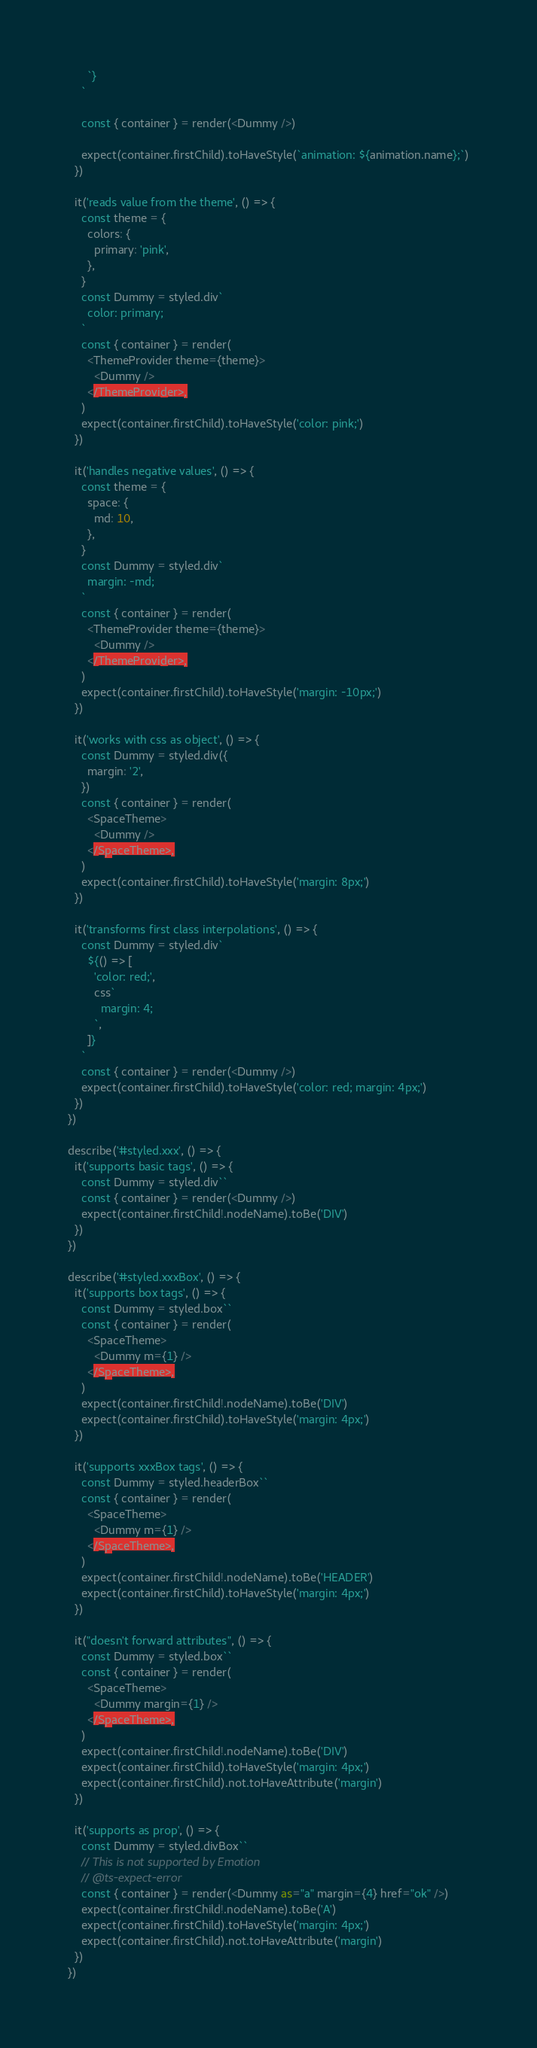<code> <loc_0><loc_0><loc_500><loc_500><_TypeScript_>      `}
    `

    const { container } = render(<Dummy />)

    expect(container.firstChild).toHaveStyle(`animation: ${animation.name};`)
  })

  it('reads value from the theme', () => {
    const theme = {
      colors: {
        primary: 'pink',
      },
    }
    const Dummy = styled.div`
      color: primary;
    `
    const { container } = render(
      <ThemeProvider theme={theme}>
        <Dummy />
      </ThemeProvider>,
    )
    expect(container.firstChild).toHaveStyle('color: pink;')
  })

  it('handles negative values', () => {
    const theme = {
      space: {
        md: 10,
      },
    }
    const Dummy = styled.div`
      margin: -md;
    `
    const { container } = render(
      <ThemeProvider theme={theme}>
        <Dummy />
      </ThemeProvider>,
    )
    expect(container.firstChild).toHaveStyle('margin: -10px;')
  })

  it('works with css as object', () => {
    const Dummy = styled.div({
      margin: '2',
    })
    const { container } = render(
      <SpaceTheme>
        <Dummy />
      </SpaceTheme>,
    )
    expect(container.firstChild).toHaveStyle('margin: 8px;')
  })

  it('transforms first class interpolations', () => {
    const Dummy = styled.div`
      ${() => [
        'color: red;',
        css`
          margin: 4;
        `,
      ]}
    `
    const { container } = render(<Dummy />)
    expect(container.firstChild).toHaveStyle('color: red; margin: 4px;')
  })
})

describe('#styled.xxx', () => {
  it('supports basic tags', () => {
    const Dummy = styled.div``
    const { container } = render(<Dummy />)
    expect(container.firstChild!.nodeName).toBe('DIV')
  })
})

describe('#styled.xxxBox', () => {
  it('supports box tags', () => {
    const Dummy = styled.box``
    const { container } = render(
      <SpaceTheme>
        <Dummy m={1} />
      </SpaceTheme>,
    )
    expect(container.firstChild!.nodeName).toBe('DIV')
    expect(container.firstChild).toHaveStyle('margin: 4px;')
  })

  it('supports xxxBox tags', () => {
    const Dummy = styled.headerBox``
    const { container } = render(
      <SpaceTheme>
        <Dummy m={1} />
      </SpaceTheme>,
    )
    expect(container.firstChild!.nodeName).toBe('HEADER')
    expect(container.firstChild).toHaveStyle('margin: 4px;')
  })

  it("doesn't forward attributes", () => {
    const Dummy = styled.box``
    const { container } = render(
      <SpaceTheme>
        <Dummy margin={1} />
      </SpaceTheme>,
    )
    expect(container.firstChild!.nodeName).toBe('DIV')
    expect(container.firstChild).toHaveStyle('margin: 4px;')
    expect(container.firstChild).not.toHaveAttribute('margin')
  })

  it('supports as prop', () => {
    const Dummy = styled.divBox``
    // This is not supported by Emotion
    // @ts-expect-error
    const { container } = render(<Dummy as="a" margin={4} href="ok" />)
    expect(container.firstChild!.nodeName).toBe('A')
    expect(container.firstChild).toHaveStyle('margin: 4px;')
    expect(container.firstChild).not.toHaveAttribute('margin')
  })
})
</code> 